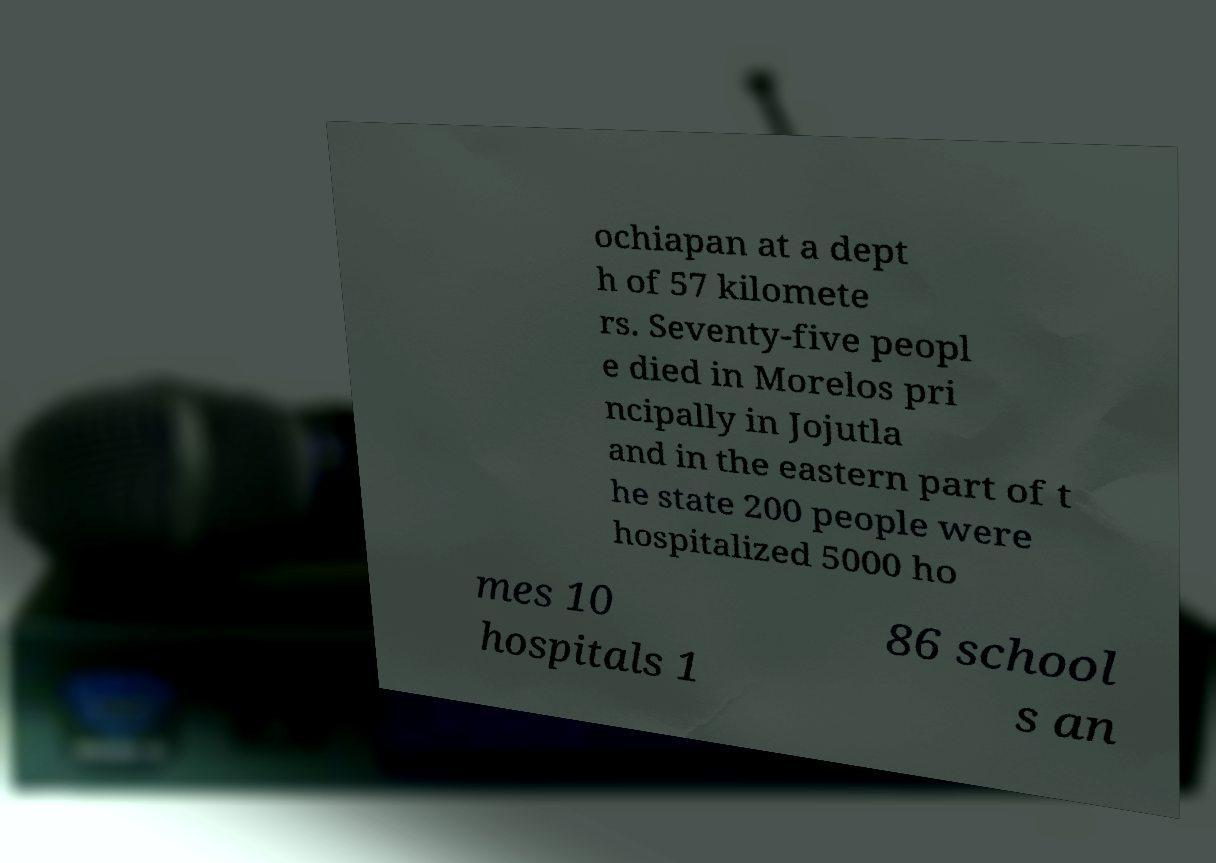What messages or text are displayed in this image? I need them in a readable, typed format. ochiapan at a dept h of 57 kilomete rs. Seventy-five peopl e died in Morelos pri ncipally in Jojutla and in the eastern part of t he state 200 people were hospitalized 5000 ho mes 10 hospitals 1 86 school s an 